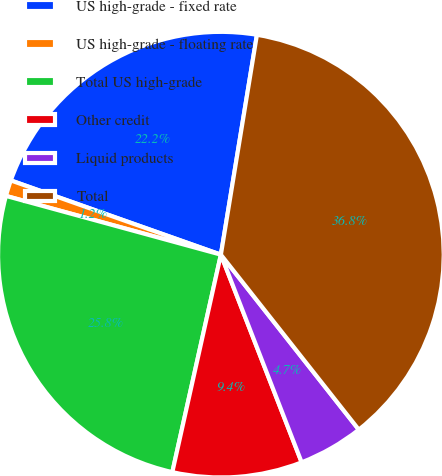Convert chart. <chart><loc_0><loc_0><loc_500><loc_500><pie_chart><fcel>US high-grade - fixed rate<fcel>US high-grade - floating rate<fcel>Total US high-grade<fcel>Other credit<fcel>Liquid products<fcel>Total<nl><fcel>22.18%<fcel>1.16%<fcel>25.75%<fcel>9.4%<fcel>4.72%<fcel>36.79%<nl></chart> 